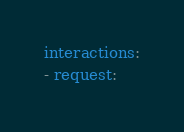Convert code to text. <code><loc_0><loc_0><loc_500><loc_500><_YAML_>interactions:
- request:</code> 